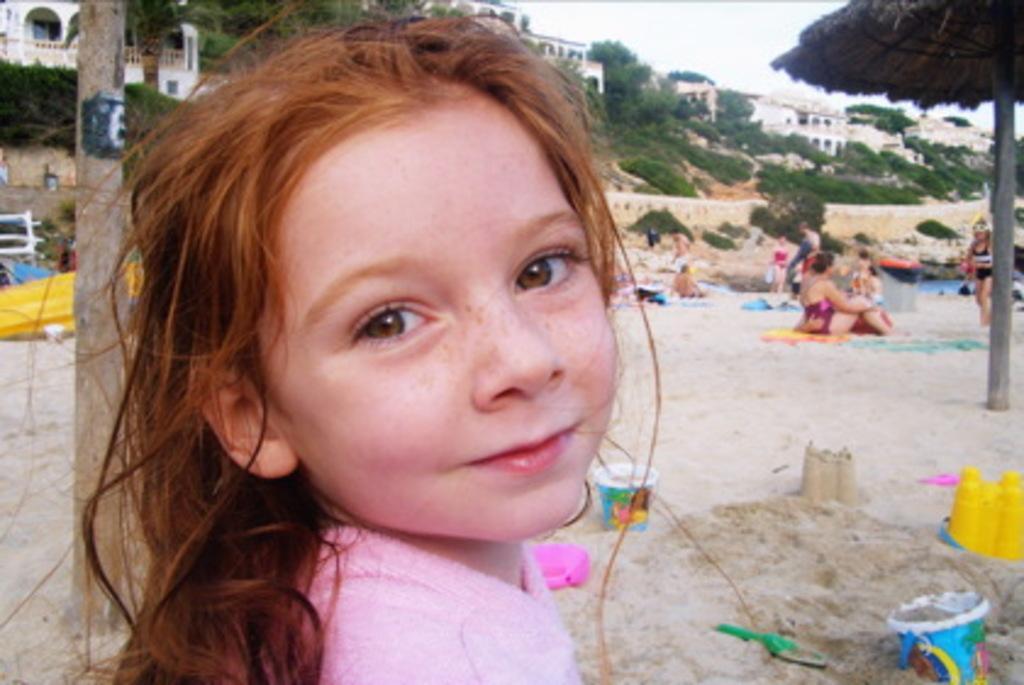Please provide a concise description of this image. In this image I can see the person with pink color dress. To the back of the person I can see few people sitting on the sand. I can also see the building, many trees and the sky in the background. 